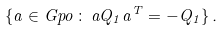<formula> <loc_0><loc_0><loc_500><loc_500>\{ \L a \in \L G p o \, \colon \, \L a Q _ { 1 } \L a ^ { T } = - Q _ { 1 } \} \, .</formula> 